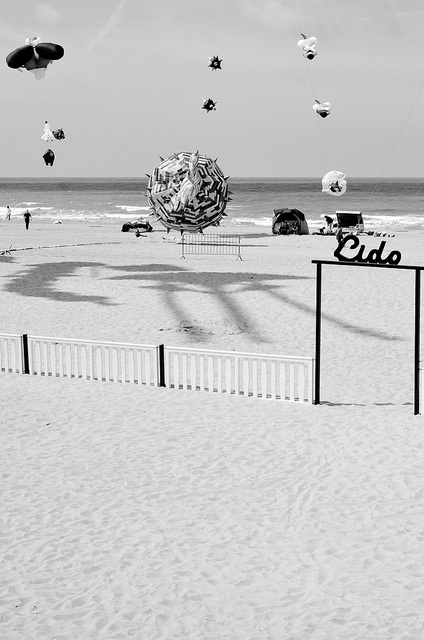Describe the objects in this image and their specific colors. I can see kite in lightgray, black, darkgray, and gray tones, kite in lightgray, gainsboro, darkgray, black, and gray tones, kite in lightgray, darkgray, black, and gray tones, kite in lightgray, darkgray, black, and gray tones, and kite in lightgray, darkgray, black, and gray tones in this image. 